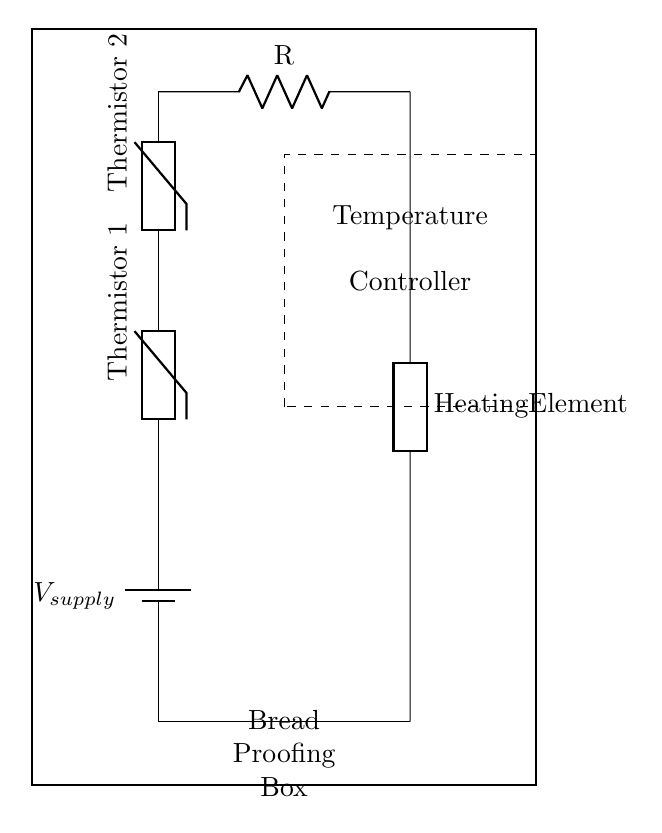What is the main purpose of this circuit? The primary purpose of this circuit is temperature control within a bread proofing box, utilizing thermistors and a heating element for maintaining an ideal temperature for dough rising.
Answer: Temperature control How many thermistors are in the circuit? There are two thermistors connected in series in the circuit configuration, which help in measuring the temperature together.
Answer: Two Which component emits heat in the circuit? The heating element is the component responsible for generating heat, as indicated in the circuit diagram.
Answer: Heating element What type of connection do the thermistors have? The thermistors are connected in series, indicated by their arrangement one after the other in the circuit.
Answer: Series What role does the temperature controller play in this circuit? The temperature controller receives input from the thermistors and manages the operation of the heating element to maintain the desired temperature within the bread proofing box.
Answer: Temperature management What is the configuration of the circuit? The configuration of the circuit is a series circuit, where the components are arranged in a single path for the current to flow, with thermistors and resistors connected in line.
Answer: Series circuit 